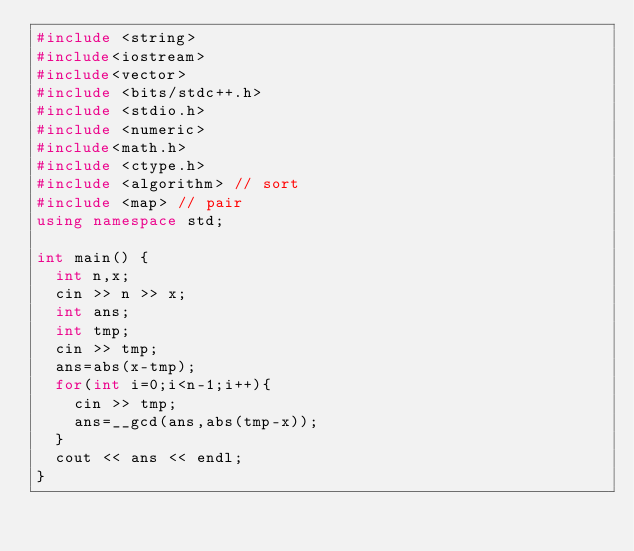<code> <loc_0><loc_0><loc_500><loc_500><_C++_>#include <string>
#include<iostream>
#include<vector>
#include <bits/stdc++.h>
#include <stdio.h>
#include <numeric>
#include<math.h>
#include <ctype.h>
#include <algorithm> // sort
#include <map> // pair
using namespace std;

int main() {
  int n,x;
  cin >> n >> x;
  int ans;
  int tmp;
  cin >> tmp;
  ans=abs(x-tmp);
  for(int i=0;i<n-1;i++){
    cin >> tmp;
    ans=__gcd(ans,abs(tmp-x));
  }
  cout << ans << endl;
}</code> 